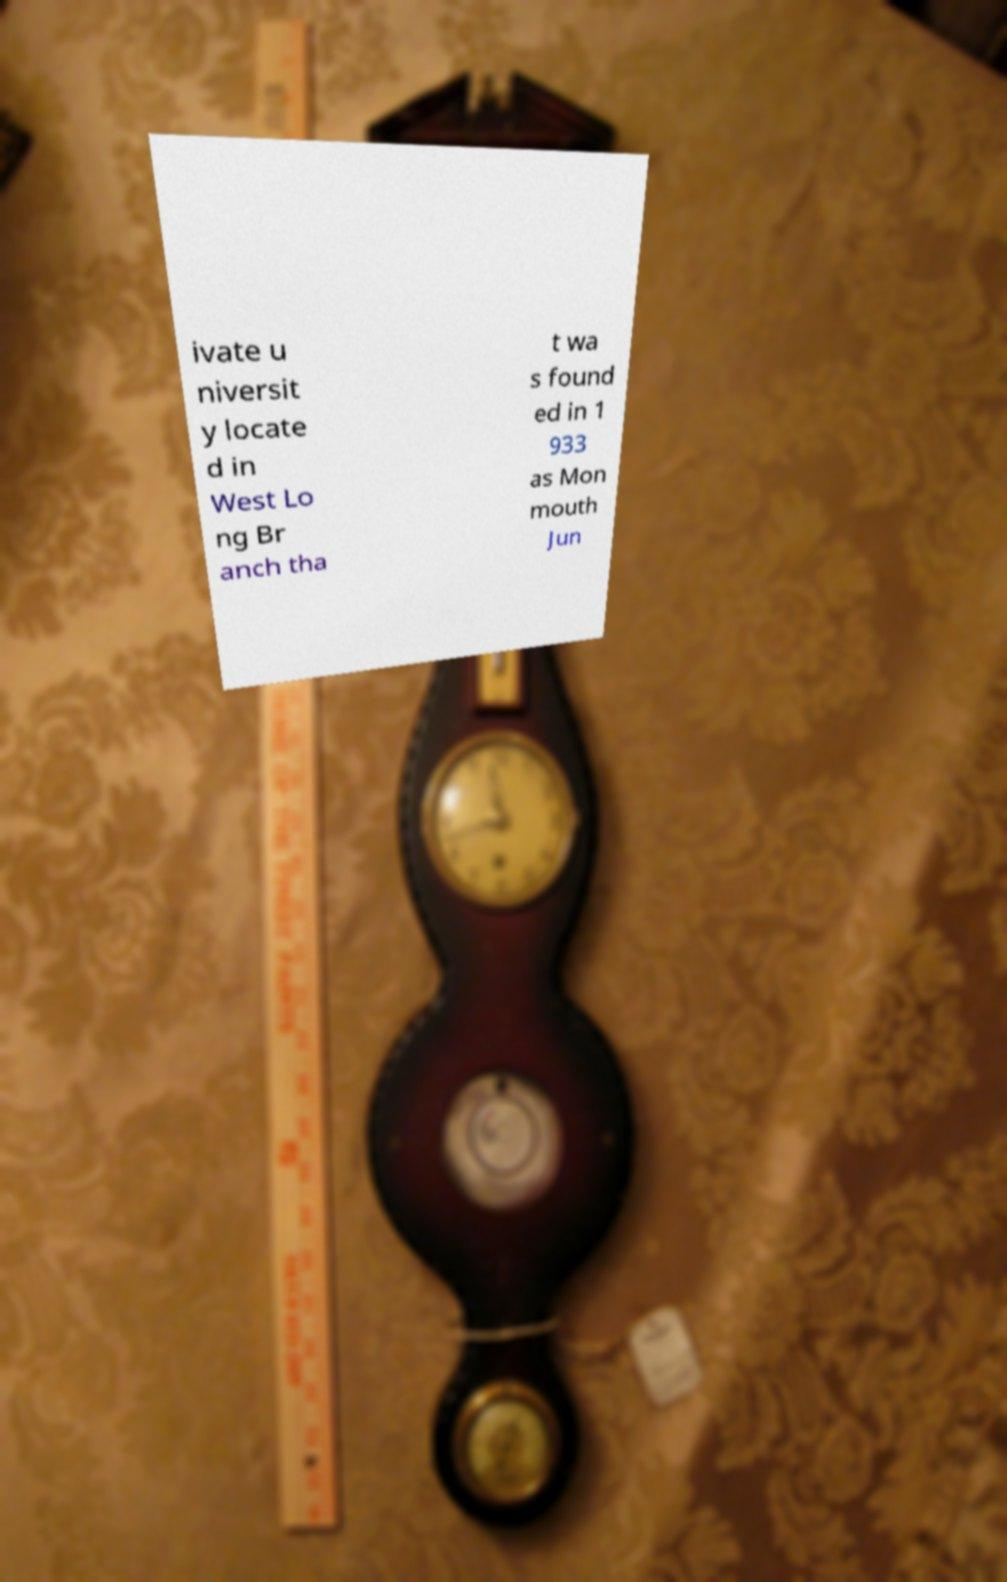Please identify and transcribe the text found in this image. ivate u niversit y locate d in West Lo ng Br anch tha t wa s found ed in 1 933 as Mon mouth Jun 